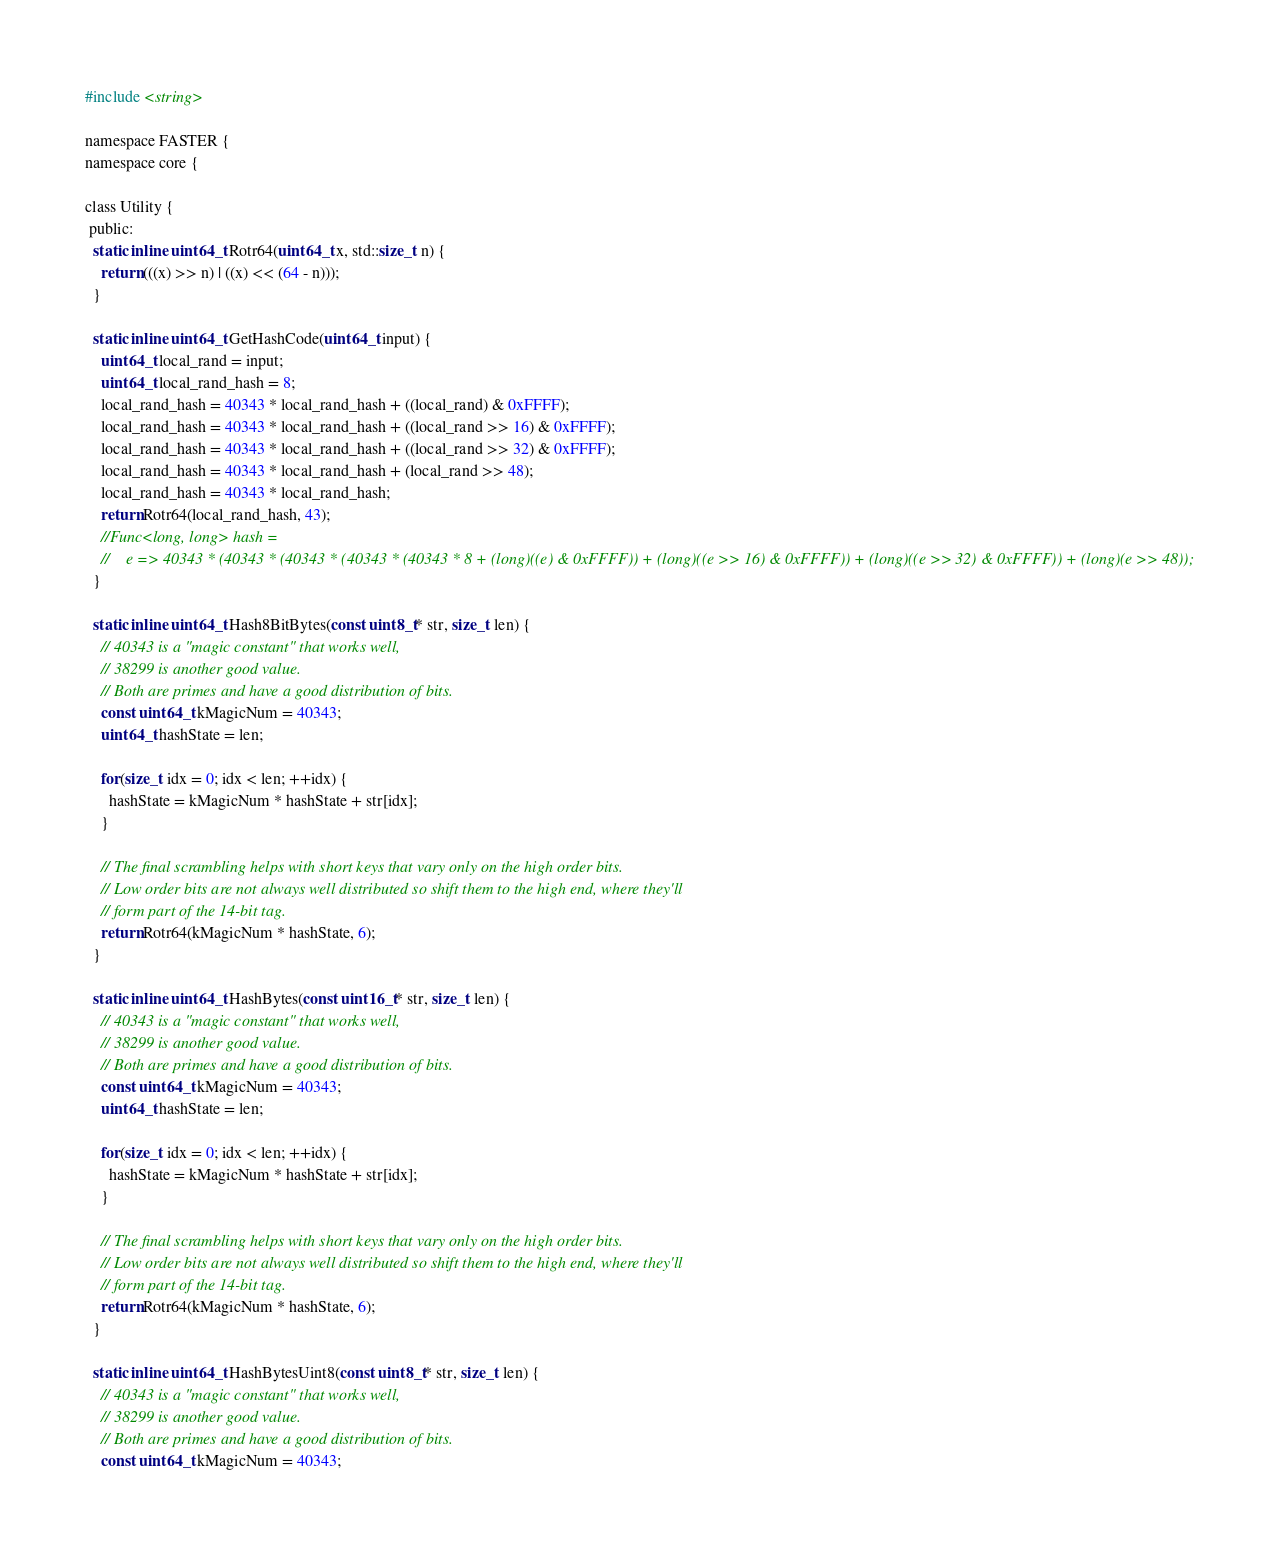Convert code to text. <code><loc_0><loc_0><loc_500><loc_500><_C_>#include <string>

namespace FASTER {
namespace core {

class Utility {
 public:
  static inline uint64_t Rotr64(uint64_t x, std::size_t n) {
    return (((x) >> n) | ((x) << (64 - n)));
  }

  static inline uint64_t GetHashCode(uint64_t input) {
    uint64_t local_rand = input;
    uint64_t local_rand_hash = 8;
    local_rand_hash = 40343 * local_rand_hash + ((local_rand) & 0xFFFF);
    local_rand_hash = 40343 * local_rand_hash + ((local_rand >> 16) & 0xFFFF);
    local_rand_hash = 40343 * local_rand_hash + ((local_rand >> 32) & 0xFFFF);
    local_rand_hash = 40343 * local_rand_hash + (local_rand >> 48);
    local_rand_hash = 40343 * local_rand_hash;
    return Rotr64(local_rand_hash, 43);
    //Func<long, long> hash =
    //    e => 40343 * (40343 * (40343 * (40343 * (40343 * 8 + (long)((e) & 0xFFFF)) + (long)((e >> 16) & 0xFFFF)) + (long)((e >> 32) & 0xFFFF)) + (long)(e >> 48));
  }

  static inline uint64_t Hash8BitBytes(const uint8_t* str, size_t len) {
    // 40343 is a "magic constant" that works well,
    // 38299 is another good value.
    // Both are primes and have a good distribution of bits.
    const uint64_t kMagicNum = 40343;
    uint64_t hashState = len;

    for(size_t idx = 0; idx < len; ++idx) {
      hashState = kMagicNum * hashState + str[idx];
    }

    // The final scrambling helps with short keys that vary only on the high order bits.
    // Low order bits are not always well distributed so shift them to the high end, where they'll
    // form part of the 14-bit tag.
    return Rotr64(kMagicNum * hashState, 6);
  }

  static inline uint64_t HashBytes(const uint16_t* str, size_t len) {
    // 40343 is a "magic constant" that works well,
    // 38299 is another good value.
    // Both are primes and have a good distribution of bits.
    const uint64_t kMagicNum = 40343;
    uint64_t hashState = len;

    for(size_t idx = 0; idx < len; ++idx) {
      hashState = kMagicNum * hashState + str[idx];
    }

    // The final scrambling helps with short keys that vary only on the high order bits.
    // Low order bits are not always well distributed so shift them to the high end, where they'll
    // form part of the 14-bit tag.
    return Rotr64(kMagicNum * hashState, 6);
  }

  static inline uint64_t HashBytesUint8(const uint8_t* str, size_t len) {
    // 40343 is a "magic constant" that works well,
    // 38299 is another good value.
    // Both are primes and have a good distribution of bits.
    const uint64_t kMagicNum = 40343;</code> 